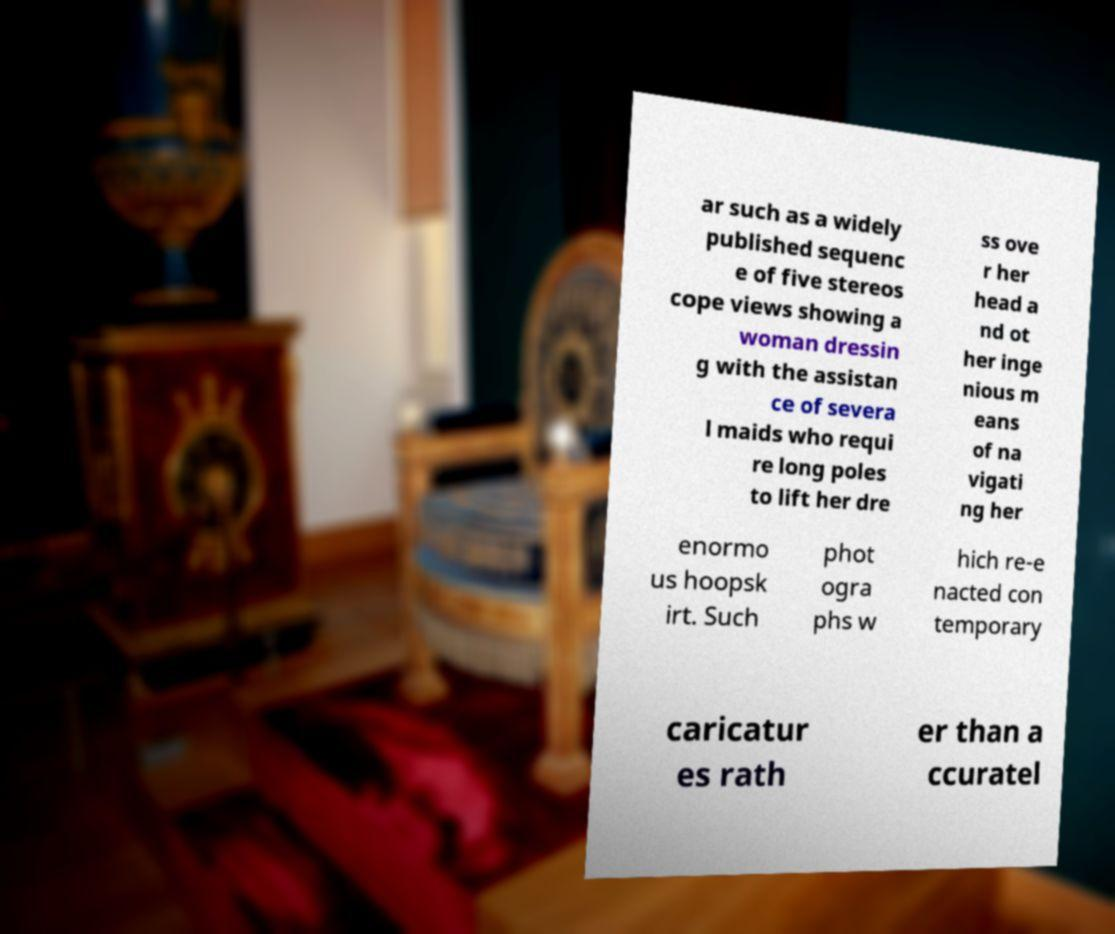Could you extract and type out the text from this image? ar such as a widely published sequenc e of five stereos cope views showing a woman dressin g with the assistan ce of severa l maids who requi re long poles to lift her dre ss ove r her head a nd ot her inge nious m eans of na vigati ng her enormo us hoopsk irt. Such phot ogra phs w hich re-e nacted con temporary caricatur es rath er than a ccuratel 